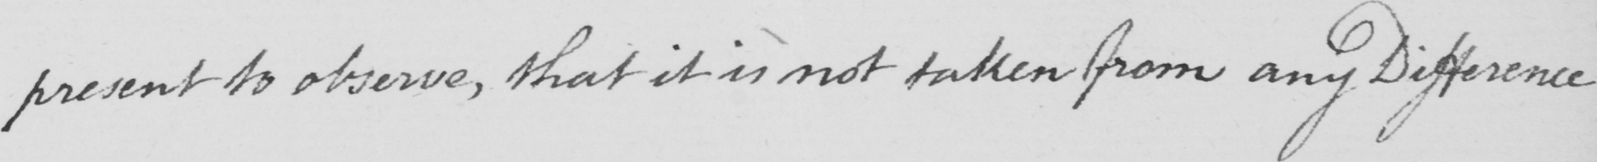What text is written in this handwritten line? present to observe , that it is not taken from any Difference 